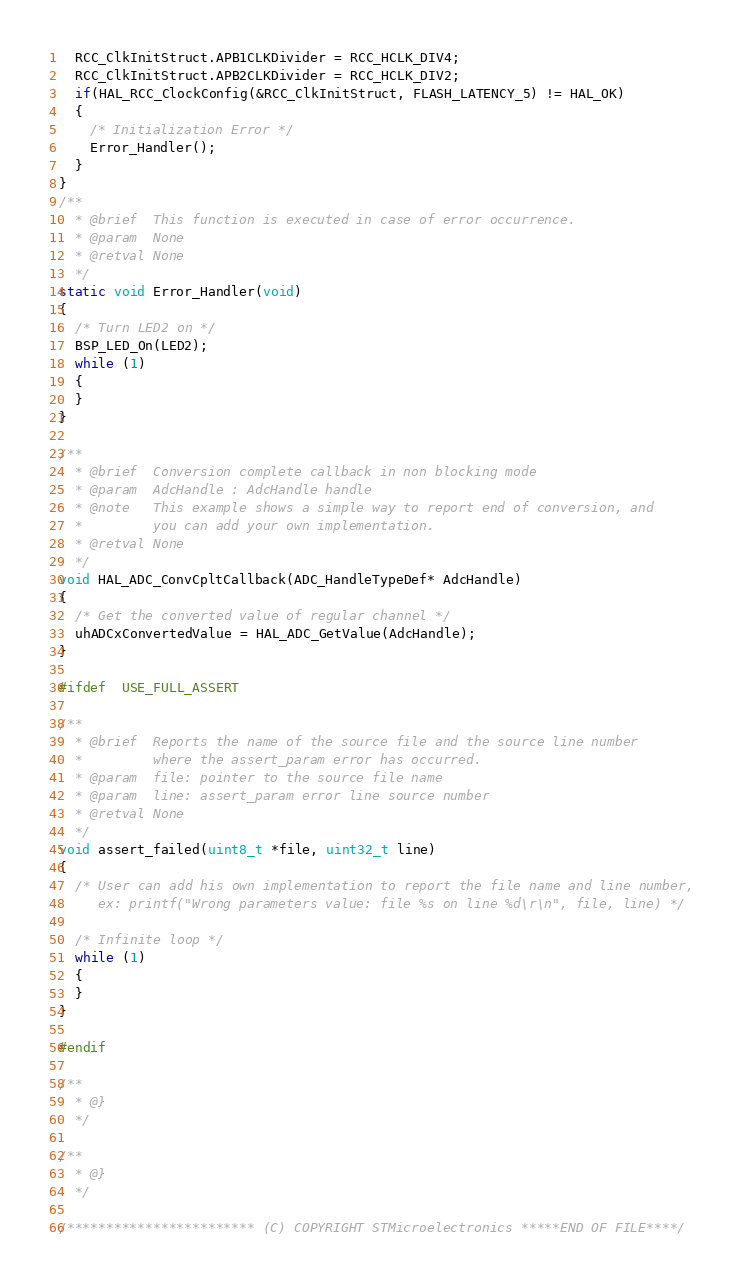Convert code to text. <code><loc_0><loc_0><loc_500><loc_500><_C_>  RCC_ClkInitStruct.APB1CLKDivider = RCC_HCLK_DIV4;  
  RCC_ClkInitStruct.APB2CLKDivider = RCC_HCLK_DIV2;  
  if(HAL_RCC_ClockConfig(&RCC_ClkInitStruct, FLASH_LATENCY_5) != HAL_OK)
  {
    /* Initialization Error */
    Error_Handler();
  }
}
/**
  * @brief  This function is executed in case of error occurrence.
  * @param  None
  * @retval None
  */
static void Error_Handler(void)
{
  /* Turn LED2 on */
  BSP_LED_On(LED2);
  while (1)
  {
  }
}

/**
  * @brief  Conversion complete callback in non blocking mode
  * @param  AdcHandle : AdcHandle handle
  * @note   This example shows a simple way to report end of conversion, and
  *         you can add your own implementation.
  * @retval None
  */
void HAL_ADC_ConvCpltCallback(ADC_HandleTypeDef* AdcHandle)
{
  /* Get the converted value of regular channel */
  uhADCxConvertedValue = HAL_ADC_GetValue(AdcHandle);
}

#ifdef  USE_FULL_ASSERT

/**
  * @brief  Reports the name of the source file and the source line number
  *         where the assert_param error has occurred.
  * @param  file: pointer to the source file name
  * @param  line: assert_param error line source number
  * @retval None
  */
void assert_failed(uint8_t *file, uint32_t line)
{
  /* User can add his own implementation to report the file name and line number,
     ex: printf("Wrong parameters value: file %s on line %d\r\n", file, line) */

  /* Infinite loop */
  while (1)
  {
  }
}

#endif

/**
  * @}
  */

/**
  * @}
  */

/************************ (C) COPYRIGHT STMicroelectronics *****END OF FILE****/
</code> 